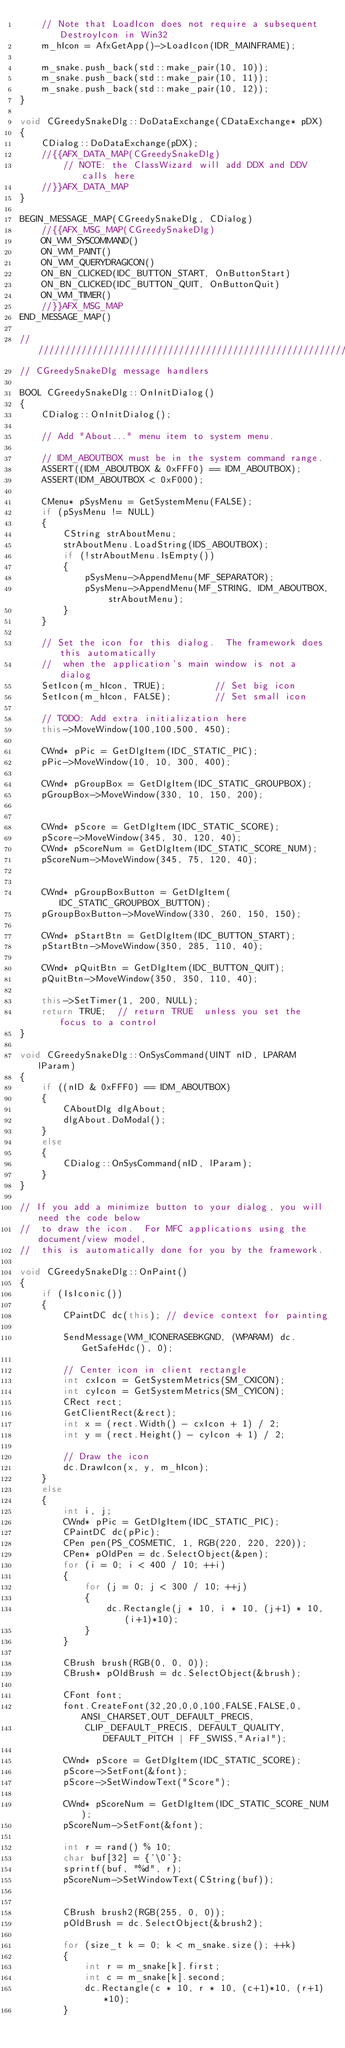Convert code to text. <code><loc_0><loc_0><loc_500><loc_500><_C++_>	// Note that LoadIcon does not require a subsequent DestroyIcon in Win32
	m_hIcon = AfxGetApp()->LoadIcon(IDR_MAINFRAME);

    m_snake.push_back(std::make_pair(10, 10));
    m_snake.push_back(std::make_pair(10, 11));
    m_snake.push_back(std::make_pair(10, 12));
}

void CGreedySnakeDlg::DoDataExchange(CDataExchange* pDX)
{
	CDialog::DoDataExchange(pDX);
	//{{AFX_DATA_MAP(CGreedySnakeDlg)
		// NOTE: the ClassWizard will add DDX and DDV calls here
	//}}AFX_DATA_MAP
}

BEGIN_MESSAGE_MAP(CGreedySnakeDlg, CDialog)
	//{{AFX_MSG_MAP(CGreedySnakeDlg)
	ON_WM_SYSCOMMAND()
	ON_WM_PAINT()
	ON_WM_QUERYDRAGICON()
	ON_BN_CLICKED(IDC_BUTTON_START, OnButtonStart)
	ON_BN_CLICKED(IDC_BUTTON_QUIT, OnButtonQuit)
	ON_WM_TIMER()
	//}}AFX_MSG_MAP
END_MESSAGE_MAP()

/////////////////////////////////////////////////////////////////////////////
// CGreedySnakeDlg message handlers

BOOL CGreedySnakeDlg::OnInitDialog()
{
	CDialog::OnInitDialog();

	// Add "About..." menu item to system menu.

	// IDM_ABOUTBOX must be in the system command range.
	ASSERT((IDM_ABOUTBOX & 0xFFF0) == IDM_ABOUTBOX);
	ASSERT(IDM_ABOUTBOX < 0xF000);

	CMenu* pSysMenu = GetSystemMenu(FALSE);
	if (pSysMenu != NULL)
	{
		CString strAboutMenu;
		strAboutMenu.LoadString(IDS_ABOUTBOX);
		if (!strAboutMenu.IsEmpty())
		{
			pSysMenu->AppendMenu(MF_SEPARATOR);
			pSysMenu->AppendMenu(MF_STRING, IDM_ABOUTBOX, strAboutMenu);
		}
	}

	// Set the icon for this dialog.  The framework does this automatically
	//  when the application's main window is not a dialog
	SetIcon(m_hIcon, TRUE);			// Set big icon
	SetIcon(m_hIcon, FALSE);		// Set small icon
	
	// TODO: Add extra initialization here
    this->MoveWindow(100,100,500, 450);

    CWnd* pPic = GetDlgItem(IDC_STATIC_PIC);
    pPic->MoveWindow(10, 10, 300, 400);

    CWnd* pGroupBox = GetDlgItem(IDC_STATIC_GROUPBOX);
    pGroupBox->MoveWindow(330, 10, 150, 200);
    

    CWnd* pScore = GetDlgItem(IDC_STATIC_SCORE);
    pScore->MoveWindow(345, 30, 120, 40);
    CWnd* pScoreNum = GetDlgItem(IDC_STATIC_SCORE_NUM);
    pScoreNum->MoveWindow(345, 75, 120, 40);


    CWnd* pGroupBoxButton = GetDlgItem(IDC_STATIC_GROUPBOX_BUTTON);
    pGroupBoxButton->MoveWindow(330, 260, 150, 150);

    CWnd* pStartBtn = GetDlgItem(IDC_BUTTON_START);
    pStartBtn->MoveWindow(350, 285, 110, 40);

    CWnd* pQuitBtn = GetDlgItem(IDC_BUTTON_QUIT);
    pQuitBtn->MoveWindow(350, 350, 110, 40);
	
    this->SetTimer(1, 200, NULL);
	return TRUE;  // return TRUE  unless you set the focus to a control
}

void CGreedySnakeDlg::OnSysCommand(UINT nID, LPARAM lParam)
{
	if ((nID & 0xFFF0) == IDM_ABOUTBOX)
	{
		CAboutDlg dlgAbout;
		dlgAbout.DoModal();
	}
	else
	{
		CDialog::OnSysCommand(nID, lParam);
	}
}

// If you add a minimize button to your dialog, you will need the code below
//  to draw the icon.  For MFC applications using the document/view model,
//  this is automatically done for you by the framework.

void CGreedySnakeDlg::OnPaint() 
{
	if (IsIconic())
	{
		CPaintDC dc(this); // device context for painting

		SendMessage(WM_ICONERASEBKGND, (WPARAM) dc.GetSafeHdc(), 0);

		// Center icon in client rectangle
		int cxIcon = GetSystemMetrics(SM_CXICON);
		int cyIcon = GetSystemMetrics(SM_CYICON);
		CRect rect;
		GetClientRect(&rect);
		int x = (rect.Width() - cxIcon + 1) / 2;
		int y = (rect.Height() - cyIcon + 1) / 2;

		// Draw the icon
		dc.DrawIcon(x, y, m_hIcon);
	}
	else
	{
        int i, j;
        CWnd* pPic = GetDlgItem(IDC_STATIC_PIC);
        CPaintDC dc(pPic);
        CPen pen(PS_COSMETIC, 1, RGB(220, 220, 220));
        CPen* pOldPen = dc.SelectObject(&pen);
        for (i = 0; i < 400 / 10; ++i)
        {
            for (j = 0; j < 300 / 10; ++j)
            {
                dc.Rectangle(j * 10, i * 10, (j+1) * 10, (i+1)*10);
            }
        }

        CBrush brush(RGB(0, 0, 0));
        CBrush* pOldBrush = dc.SelectObject(&brush);

        CFont font;
        font.CreateFont(32,20,0,0,100,FALSE,FALSE,0,ANSI_CHARSET,OUT_DEFAULT_PRECIS,
            CLIP_DEFAULT_PRECIS, DEFAULT_QUALITY,DEFAULT_PITCH | FF_SWISS,"Arial");

        CWnd* pScore = GetDlgItem(IDC_STATIC_SCORE);
        pScore->SetFont(&font);
        pScore->SetWindowText("Score");

        CWnd* pScoreNum = GetDlgItem(IDC_STATIC_SCORE_NUM);
        pScoreNum->SetFont(&font);
        
        int r = rand() % 10;
        char buf[32] = {'\0'};
        sprintf(buf, "%d", r);
        pScoreNum->SetWindowText(CString(buf));


        CBrush brush2(RGB(255, 0, 0));
        pOldBrush = dc.SelectObject(&brush2);

        for (size_t k = 0; k < m_snake.size(); ++k)
        {
            int r = m_snake[k].first;
            int c = m_snake[k].second;
            dc.Rectangle(c * 10, r * 10, (c+1)*10, (r+1)*10);
        }

        
</code> 